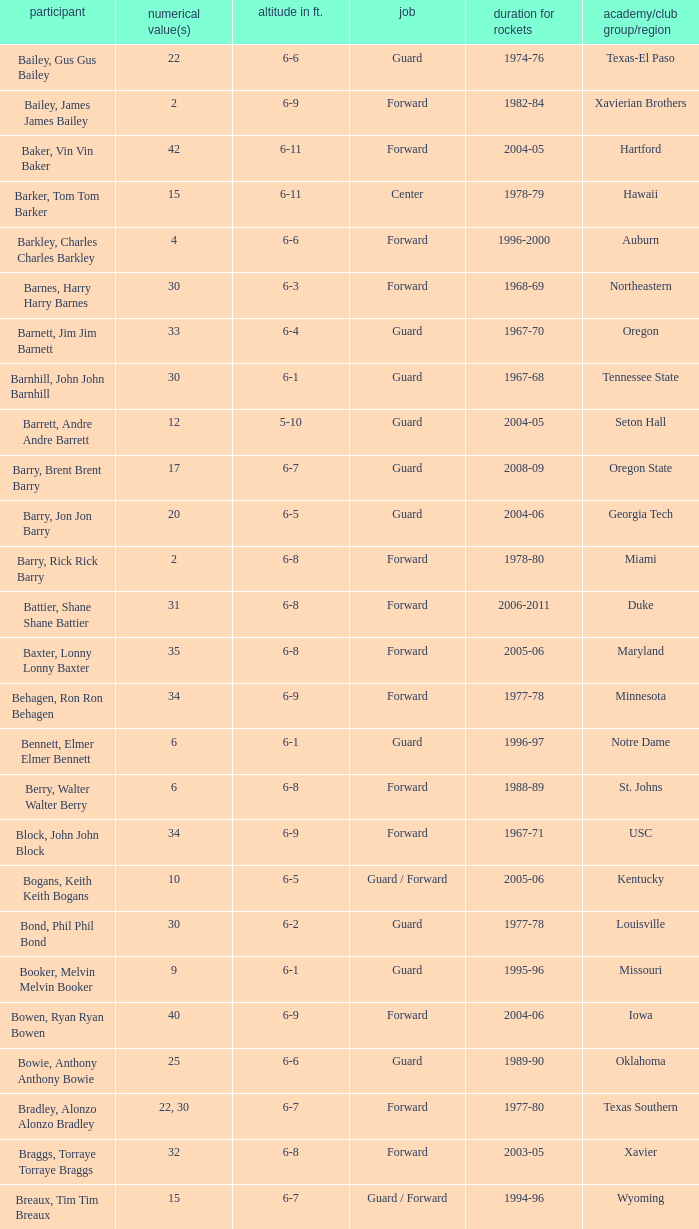What is the height of the player who attended Hartford? 6-11. 